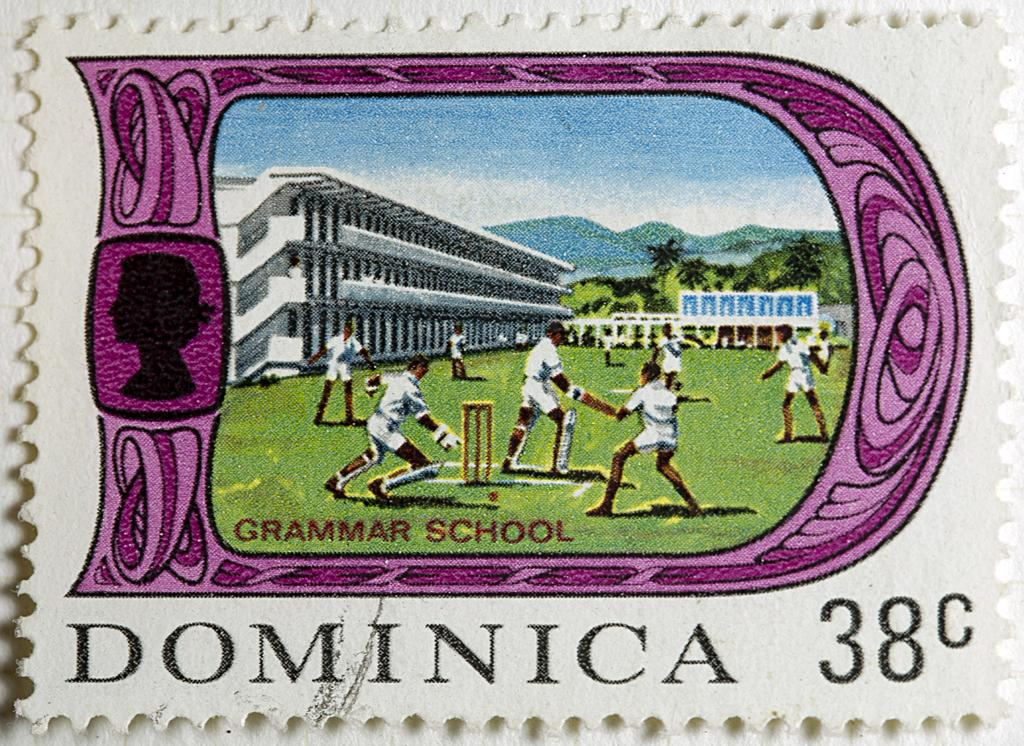<image>
Give a short and clear explanation of the subsequent image. A grammar school themed postage stamp is worth 38 cents. 